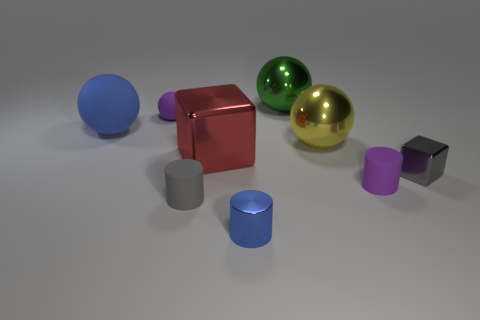What number of large rubber objects have the same color as the small shiny cylinder?
Provide a short and direct response. 1. How big is the shiny sphere right of the big green ball?
Your answer should be very brief. Large. How many purple things are the same size as the gray cube?
Provide a succinct answer. 2. What is the color of the tiny cube that is made of the same material as the small blue object?
Offer a very short reply. Gray. Is the number of tiny purple things that are to the left of the small blue metal cylinder less than the number of large blue matte cylinders?
Ensure brevity in your answer.  No. What shape is the large red thing that is the same material as the green thing?
Provide a succinct answer. Cube. How many metal things are large red blocks or tiny purple spheres?
Your answer should be compact. 1. Are there an equal number of large metal things that are left of the big rubber thing and red metal cubes?
Offer a very short reply. No. Does the ball that is to the left of the purple ball have the same color as the metal cylinder?
Make the answer very short. Yes. What is the material of the object that is in front of the small cube and on the right side of the blue metallic cylinder?
Keep it short and to the point. Rubber. 